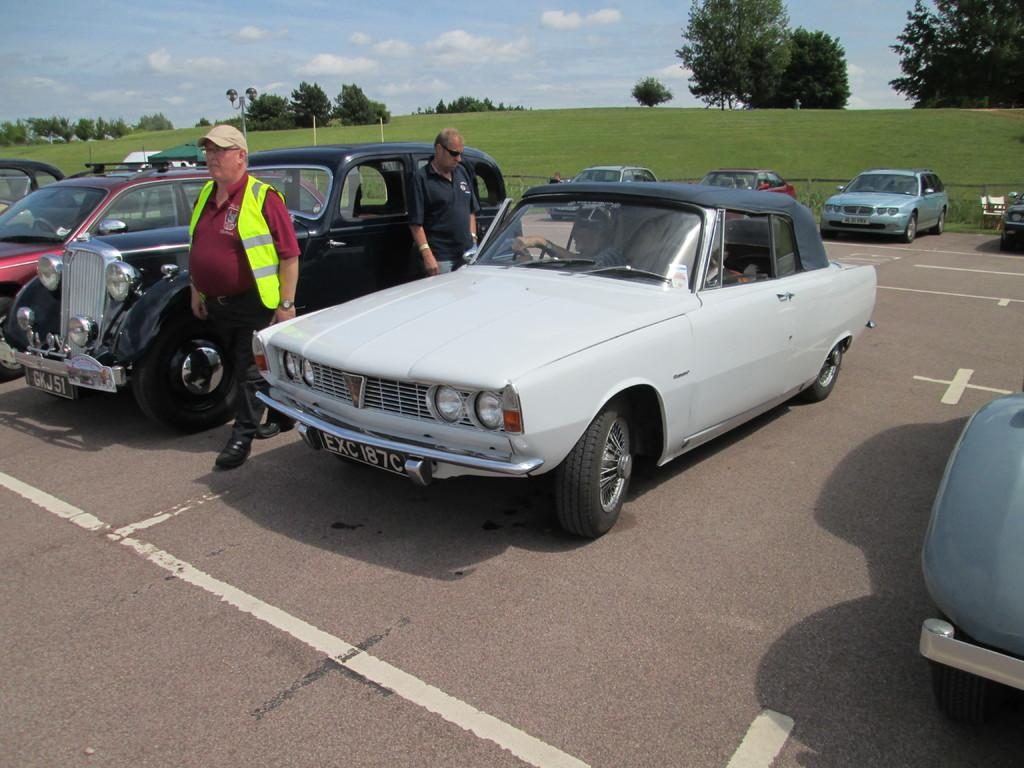What can you describe the vehicles on the road in the image? There are vehicles on the road in the image, but their specific types are not mentioned. How many people are in the image? There are two persons standing in the image. What kind of shelter is present in the image? There is a canopy tent in the image. What type of vegetation is visible in the image? Grass and trees are present in the image. What can be seen in the background of the image? The sky is visible in the background of the image. Where is the shop located in the image? There is no shop present in the image. How do the trees push the people in the image? Trees do not push people in the image; they are stationary plants. What day is depicted in the image? The day is not mentioned in the image; it could be any day. 